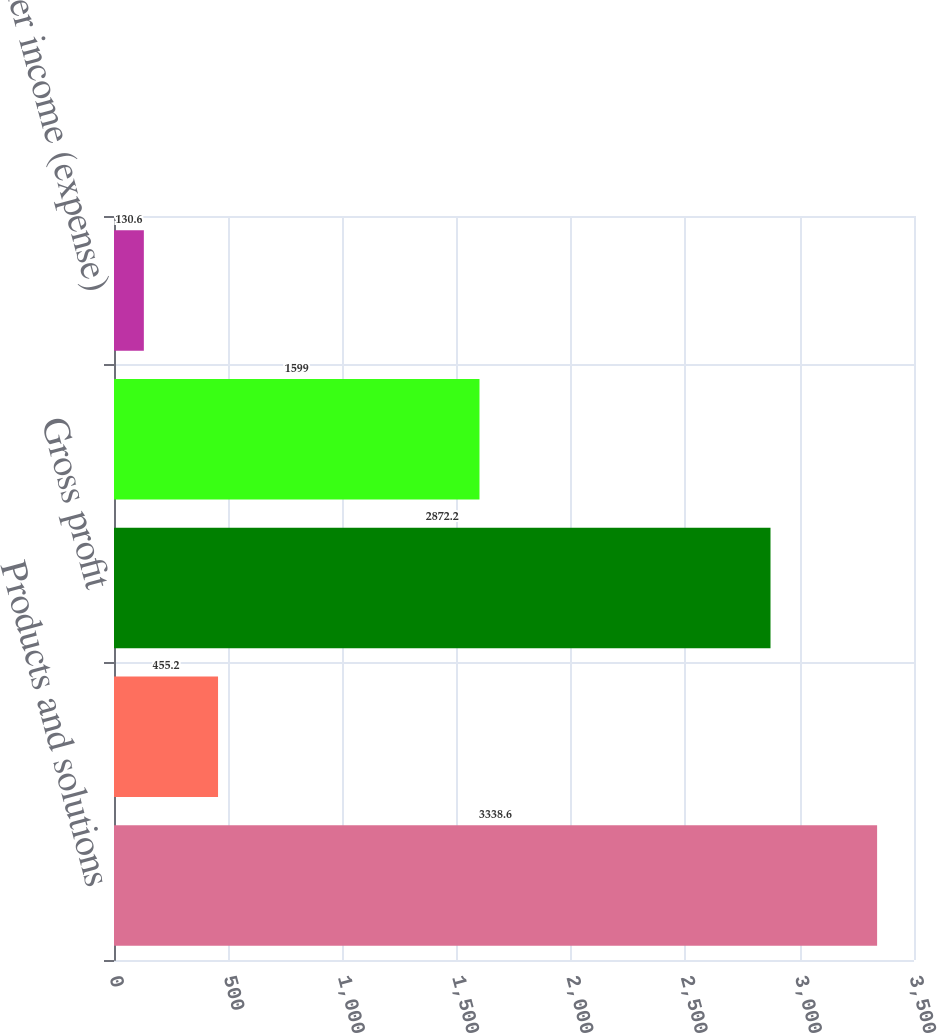Convert chart to OTSL. <chart><loc_0><loc_0><loc_500><loc_500><bar_chart><fcel>Products and solutions<fcel>Services<fcel>Gross profit<fcel>Selling general and<fcel>Other income (expense)<nl><fcel>3338.6<fcel>455.2<fcel>2872.2<fcel>1599<fcel>130.6<nl></chart> 